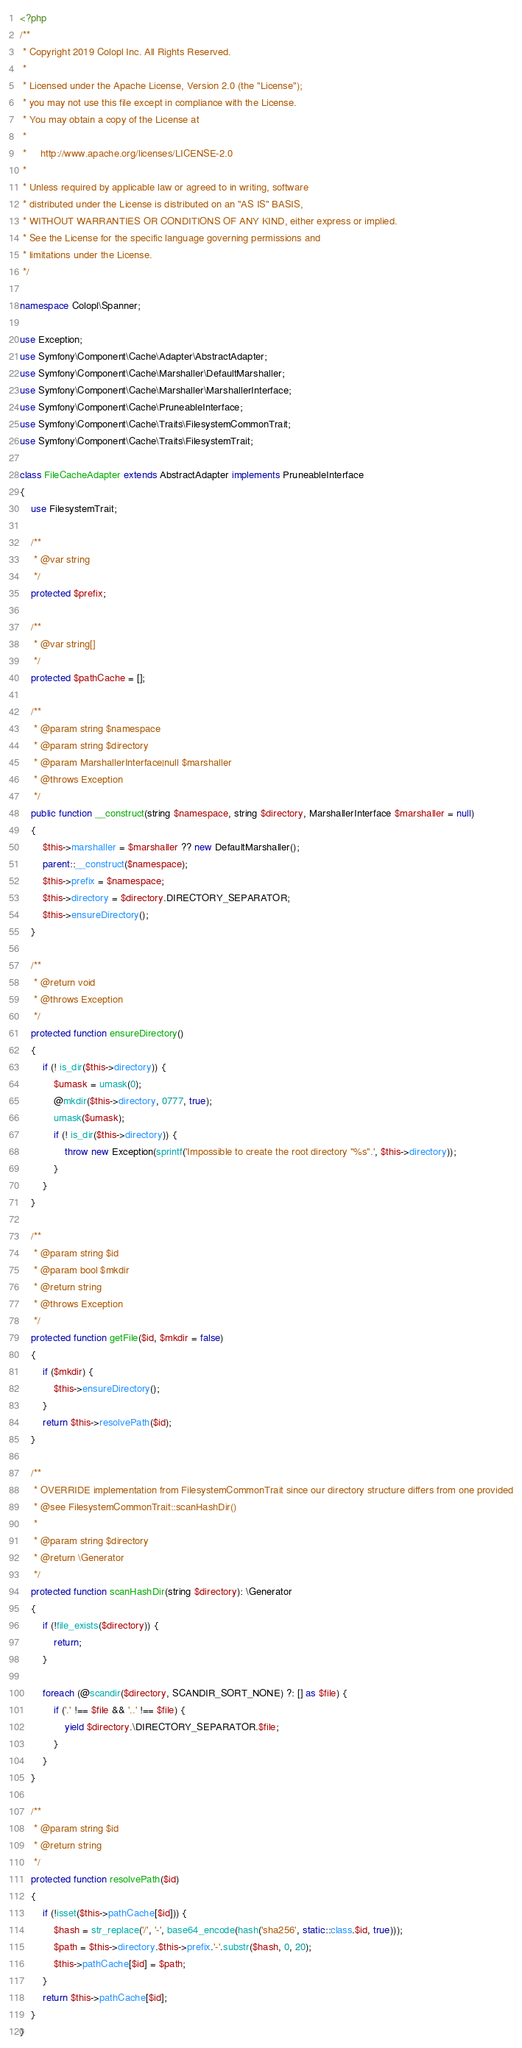<code> <loc_0><loc_0><loc_500><loc_500><_PHP_><?php
/**
 * Copyright 2019 Colopl Inc. All Rights Reserved.
 *
 * Licensed under the Apache License, Version 2.0 (the "License");
 * you may not use this file except in compliance with the License.
 * You may obtain a copy of the License at
 *
 *     http://www.apache.org/licenses/LICENSE-2.0
 *
 * Unless required by applicable law or agreed to in writing, software
 * distributed under the License is distributed on an "AS IS" BASIS,
 * WITHOUT WARRANTIES OR CONDITIONS OF ANY KIND, either express or implied.
 * See the License for the specific language governing permissions and
 * limitations under the License.
 */

namespace Colopl\Spanner;

use Exception;
use Symfony\Component\Cache\Adapter\AbstractAdapter;
use Symfony\Component\Cache\Marshaller\DefaultMarshaller;
use Symfony\Component\Cache\Marshaller\MarshallerInterface;
use Symfony\Component\Cache\PruneableInterface;
use Symfony\Component\Cache\Traits\FilesystemCommonTrait;
use Symfony\Component\Cache\Traits\FilesystemTrait;

class FileCacheAdapter extends AbstractAdapter implements PruneableInterface
{
    use FilesystemTrait;

    /**
     * @var string
     */
    protected $prefix;

    /**
     * @var string[]
     */
    protected $pathCache = [];

    /**
     * @param string $namespace
     * @param string $directory
     * @param MarshallerInterface|null $marshaller
     * @throws Exception
     */
    public function __construct(string $namespace, string $directory, MarshallerInterface $marshaller = null)
    {
        $this->marshaller = $marshaller ?? new DefaultMarshaller();
        parent::__construct($namespace);
        $this->prefix = $namespace;
        $this->directory = $directory.DIRECTORY_SEPARATOR;
        $this->ensureDirectory();
    }

    /**
     * @return void
     * @throws Exception
     */
    protected function ensureDirectory()
    {
        if (! is_dir($this->directory)) {
            $umask = umask(0);
            @mkdir($this->directory, 0777, true);
            umask($umask);
            if (! is_dir($this->directory)) {
                throw new Exception(sprintf('Impossible to create the root directory "%s".', $this->directory));
            }
        }
    }

    /**
     * @param string $id
     * @param bool $mkdir
     * @return string
     * @throws Exception
     */
    protected function getFile($id, $mkdir = false)
    {
        if ($mkdir) {
            $this->ensureDirectory();
        }
        return $this->resolvePath($id);
    }

    /**
     * OVERRIDE implementation from FilesystemCommonTrait since our directory structure differs from one provided
     * @see FilesystemCommonTrait::scanHashDir()
     *
     * @param string $directory
     * @return \Generator
     */
    protected function scanHashDir(string $directory): \Generator
    {
        if (!file_exists($directory)) {
            return;
        }

        foreach (@scandir($directory, SCANDIR_SORT_NONE) ?: [] as $file) {
            if ('.' !== $file && '..' !== $file) {
                yield $directory.\DIRECTORY_SEPARATOR.$file;
            }
        }
    }

    /**
     * @param string $id
     * @return string
     */
    protected function resolvePath($id)
    {
        if (!isset($this->pathCache[$id])) {
            $hash = str_replace('/', '-', base64_encode(hash('sha256', static::class.$id, true)));
            $path = $this->directory.$this->prefix.'-'.substr($hash, 0, 20);
            $this->pathCache[$id] = $path;
        }
        return $this->pathCache[$id];
    }
}
</code> 